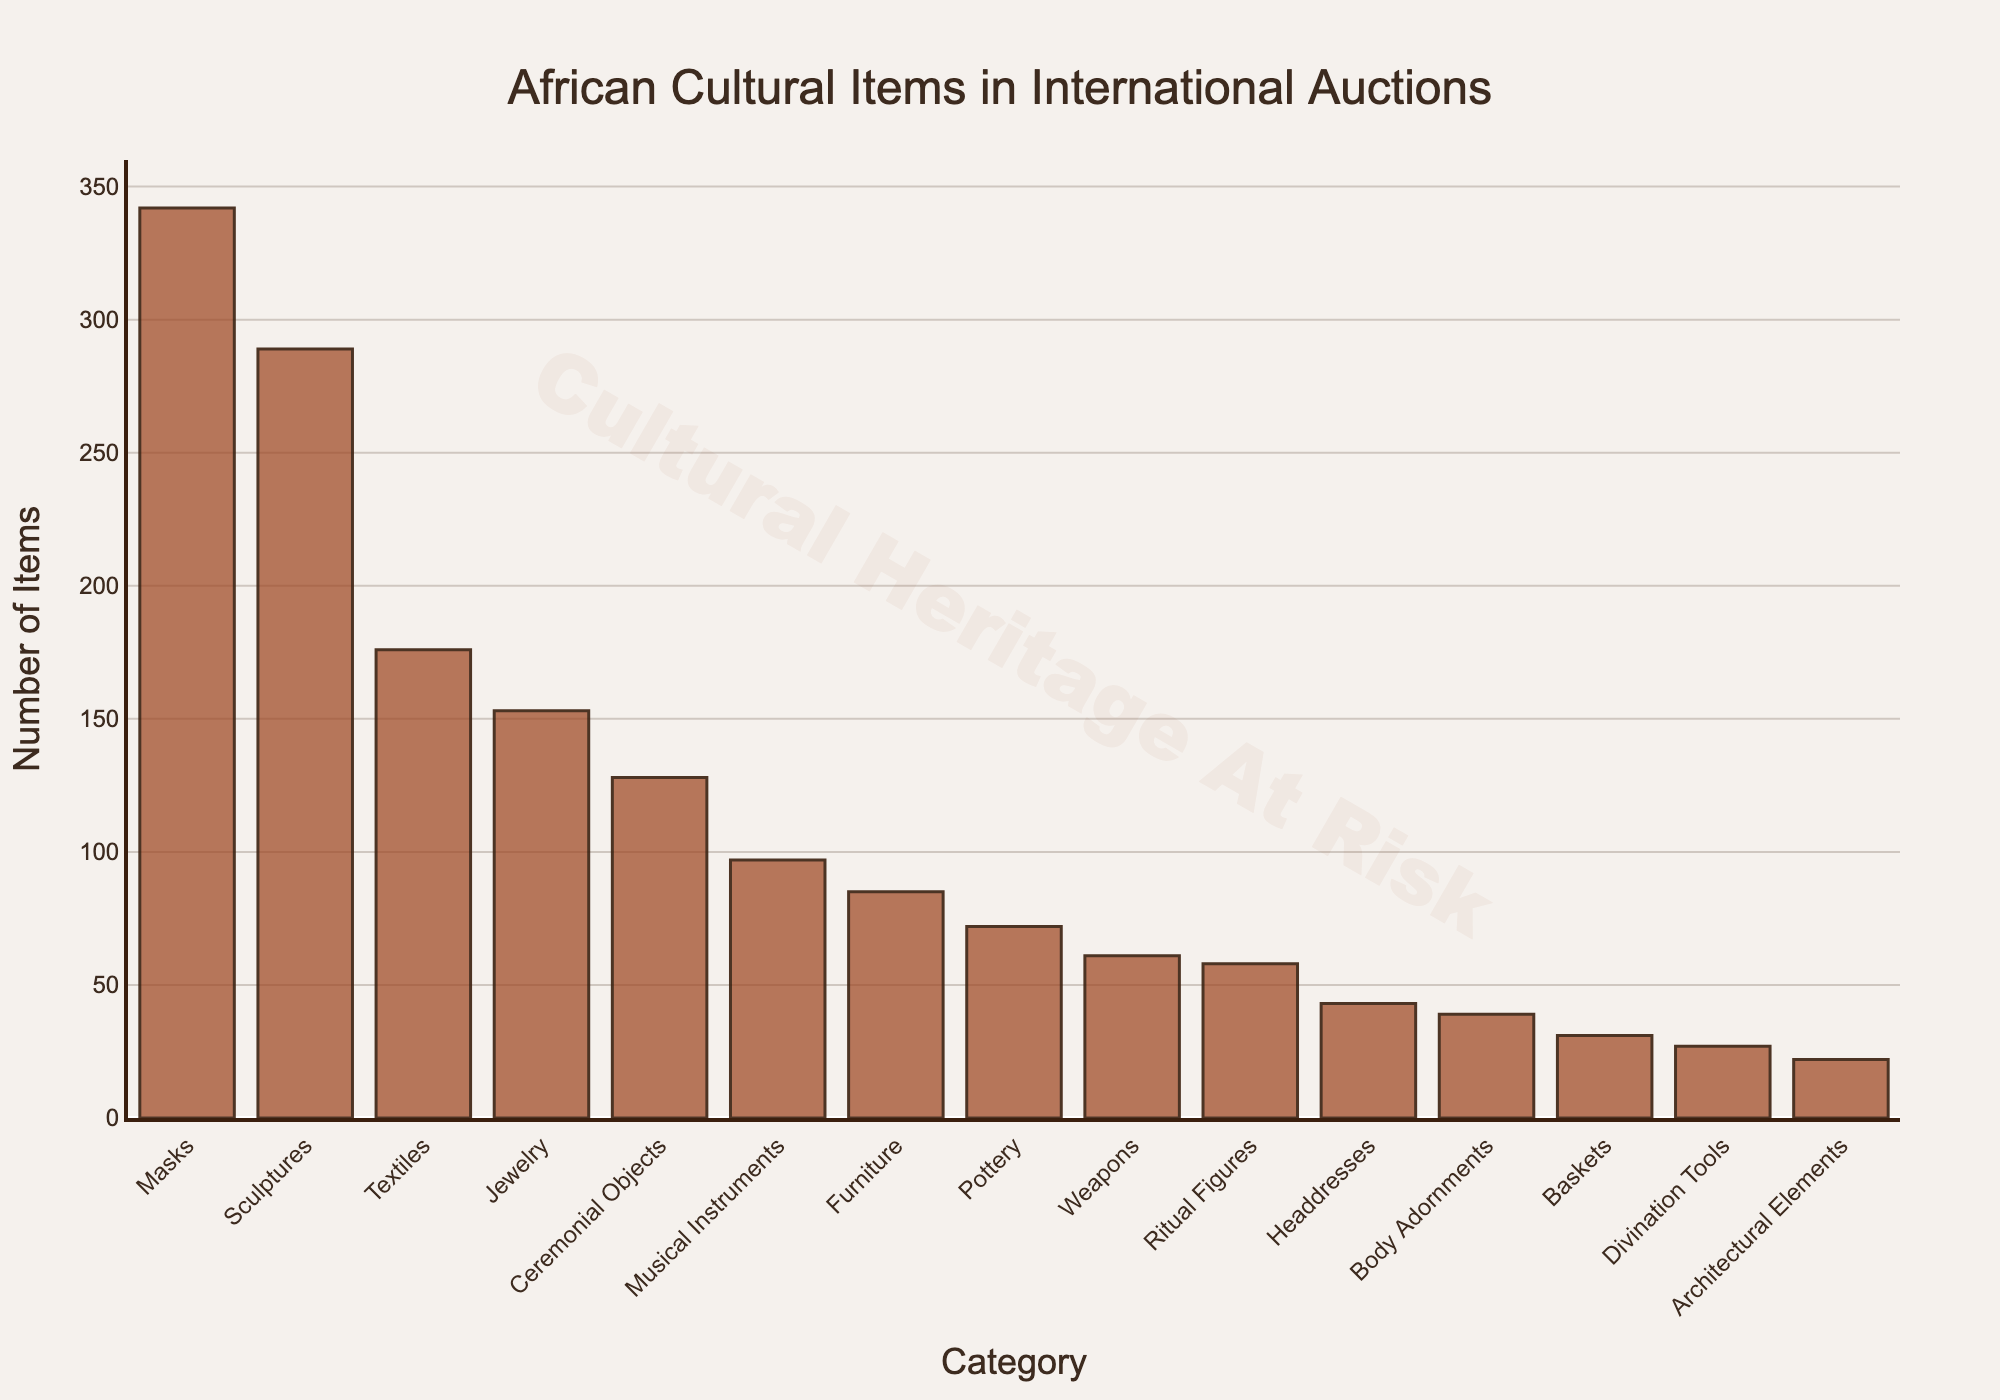Which category has the highest number of items found in international auctions? Masks have the highest bar in the chart, indicating the largest number of items.
Answer: Masks How many more items are there in the Masks category compared to the Sculptures category? The number of items for Masks is 342, and for Sculptures, it is 289. The difference is 342 - 289 = 53.
Answer: 53 Which categories have fewer than 50 items found in international auctions? From the chart, Headdresses, Body Adornments, Baskets, Divination Tools, and Architectural Elements all have bars lower than the 50 mark.
Answer: Headdresses, Body Adornments, Baskets, Divination Tools, Architectural Elements Are there more Textile items or Jewelry items found in international auctions? The height of the Textile bar is higher than the Jewelry bar. The numbers are 176 for Textiles and 153 for Jewelry.
Answer: Textiles What is the combined total number of items for Musical Instruments and Furniture categories? The number of items for Musical Instruments is 97, and for Furniture, it is 85. The total is 97 + 85 = 182.
Answer: 182 Which category has the smallest number of items found in international auctions? Architectural Elements have the shortest bar with 22 items.
Answer: Architectural Elements How many more categories have fewer items than Masks? The chart shows that all other categories have fewer items than Masks. There are a total of 15 categories, and with Masks being the highest, the remaining 14 categories all have fewer items.
Answer: 14 Which has more items, Pottery or Ritual Figures, and by how much? Pottery has 72 items, while Ritual Figures have 58 items. The difference is 72 - 58 = 14 more items in Pottery.
Answer: Pottery by 14 items What is the average number of items found in the top three categories? The top three categories are Masks, Sculptures, and Textiles, with 342, 289, and 176 items respectively. The average is (342 + 289 + 176) / 3 = 807 / 3 = 269.
Answer: 269 